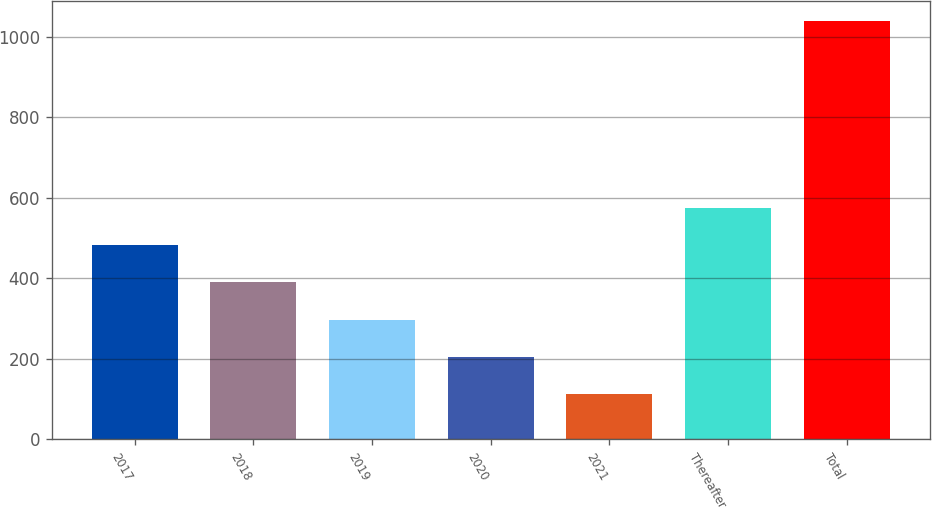<chart> <loc_0><loc_0><loc_500><loc_500><bar_chart><fcel>2017<fcel>2018<fcel>2019<fcel>2020<fcel>2021<fcel>Thereafter<fcel>Total<nl><fcel>482.4<fcel>389.8<fcel>297.2<fcel>204.6<fcel>112<fcel>575<fcel>1038<nl></chart> 